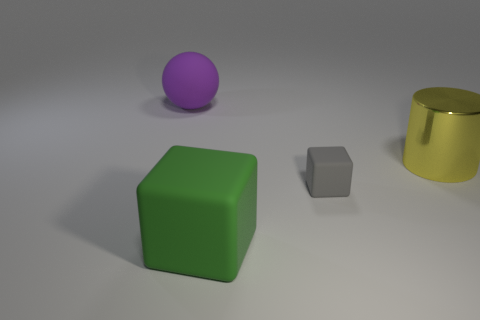If we were to group these objects based on their shape, how would they be categorized? Based on their shape, the objects could be categorized into two groups: the sphere, represented by the purple object, and the cubes, which include the green and smaller gray object. The yellow object, being cylindrical, would form a category of its own. 